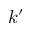Convert formula to latex. <formula><loc_0><loc_0><loc_500><loc_500>k ^ { \prime }</formula> 